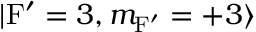Convert formula to latex. <formula><loc_0><loc_0><loc_500><loc_500>| F ^ { \prime } = 3 , m _ { F ^ { \prime } } = + 3 \rangle</formula> 